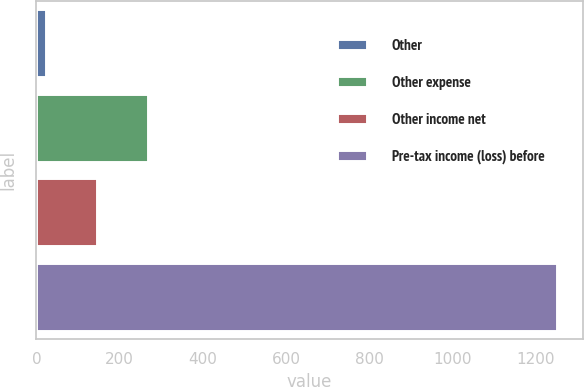<chart> <loc_0><loc_0><loc_500><loc_500><bar_chart><fcel>Other<fcel>Other expense<fcel>Other income net<fcel>Pre-tax income (loss) before<nl><fcel>23<fcel>268.4<fcel>145.7<fcel>1250<nl></chart> 